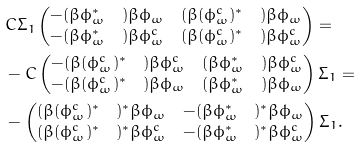<formula> <loc_0><loc_0><loc_500><loc_500>& C \Sigma _ { 1 } \begin{pmatrix} - ( \beta { \phi } _ { \omega } ^ { * } \quad ) \beta \phi _ { \omega } & ( \beta ( \phi _ { \omega } ^ { c } ) ^ { * } \quad ) \beta \phi _ { \omega } \\ - ( \beta \phi _ { \omega } ^ { * } { \quad } ) \beta \phi _ { \omega } ^ { c } & ( \beta ( \phi _ { \omega } ^ { c } ) ^ { * } \quad ) \beta \phi _ { \omega } ^ { c } \end{pmatrix} = \\ & - C \begin{pmatrix} - ( \beta ( \phi _ { \omega } ^ { c } ) ^ { * } \quad ) \beta \phi _ { \omega } ^ { c } & ( \beta { \phi } _ { \omega } ^ { * } \quad ) \beta \phi _ { \omega } ^ { c } \\ - ( \beta ( \phi _ { \omega } ^ { c } ) ^ { * } \quad ) \beta \phi _ { \omega } & ( \beta { \phi } _ { \omega } ^ { * } \quad ) \beta \phi _ { \omega } \end{pmatrix} \Sigma _ { 1 } = \\ & - \begin{pmatrix} ( \beta ( \phi _ { \omega } ^ { c } ) ^ { * } \quad ) ^ { * } \beta \phi _ { \omega } & - ( \beta { \phi } _ { \omega } ^ { * } \quad ) ^ { * } \beta \phi _ { \omega } \\ ( \beta ( \phi _ { \omega } ^ { c } ) ^ { * } \quad ) ^ { * } \beta \phi _ { \omega } ^ { c } & - ( \beta { \phi } _ { \omega } ^ { * } \quad ) ^ { * } \beta \phi _ { \omega } ^ { c } \end{pmatrix} \Sigma _ { 1 } .</formula> 